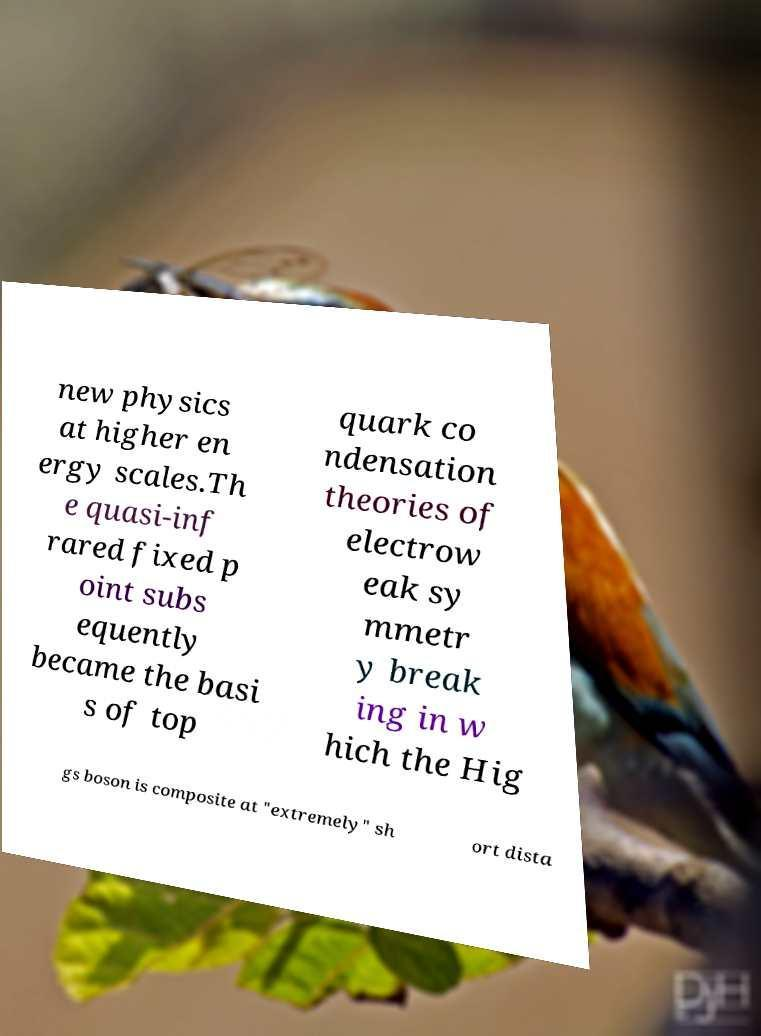Could you extract and type out the text from this image? new physics at higher en ergy scales.Th e quasi-inf rared fixed p oint subs equently became the basi s of top quark co ndensation theories of electrow eak sy mmetr y break ing in w hich the Hig gs boson is composite at "extremely" sh ort dista 